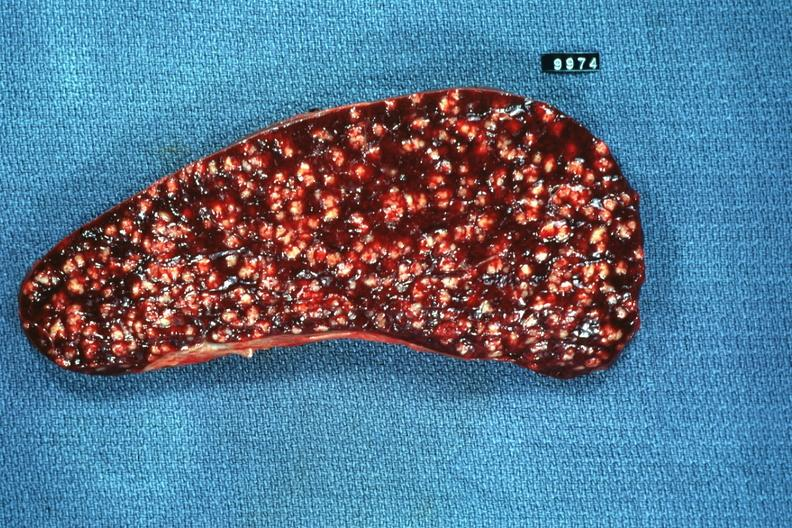s spleen present?
Answer the question using a single word or phrase. Yes 